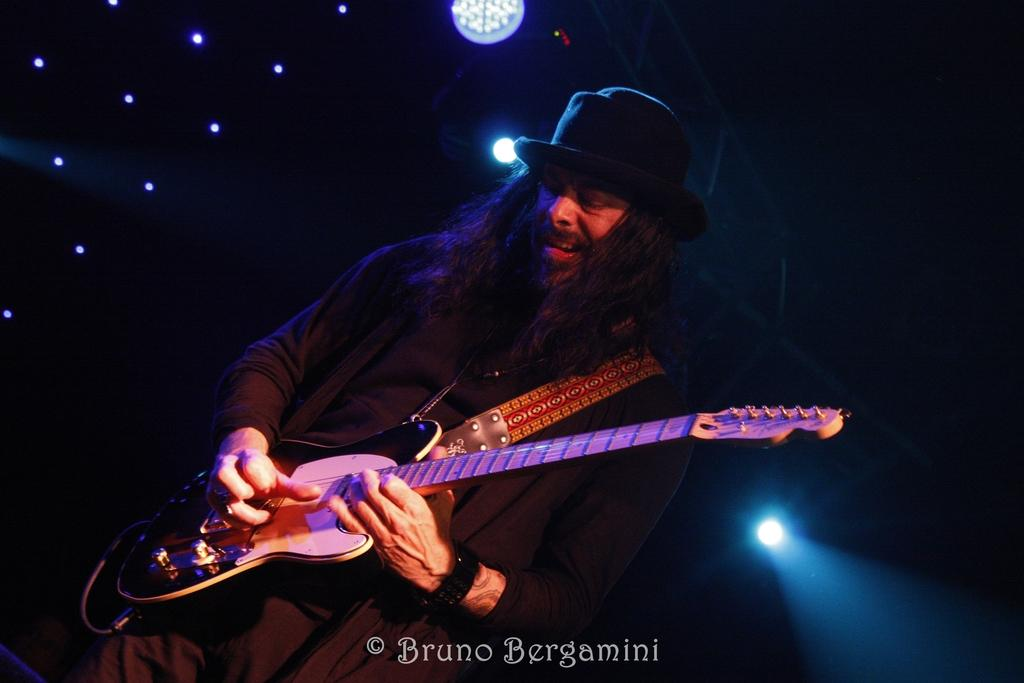What is the overall lighting condition in the image? The image is dark. What is the man in the image doing? The man is playing a guitar. What type of clothing is the man wearing on his head? The man is wearing a black hat. Can you identify any light sources in the image? Yes, there are lights visible in the image. What type of jelly is the man eating during his guitar performance? There is no jelly present in the image, and the man is not eating anything. How does the man kick the guitar during his performance? The man is not kicking the guitar; he is playing it with his hands. 